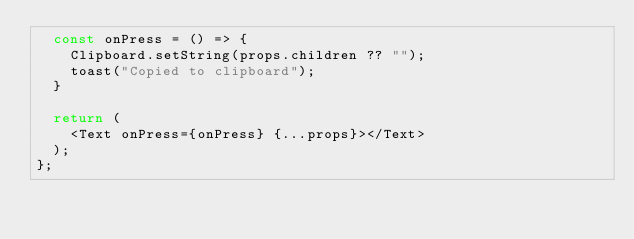Convert code to text. <code><loc_0><loc_0><loc_500><loc_500><_TypeScript_>  const onPress = () => {
    Clipboard.setString(props.children ?? "");
    toast("Copied to clipboard");
  }

  return (
    <Text onPress={onPress} {...props}></Text>
  );
};
</code> 